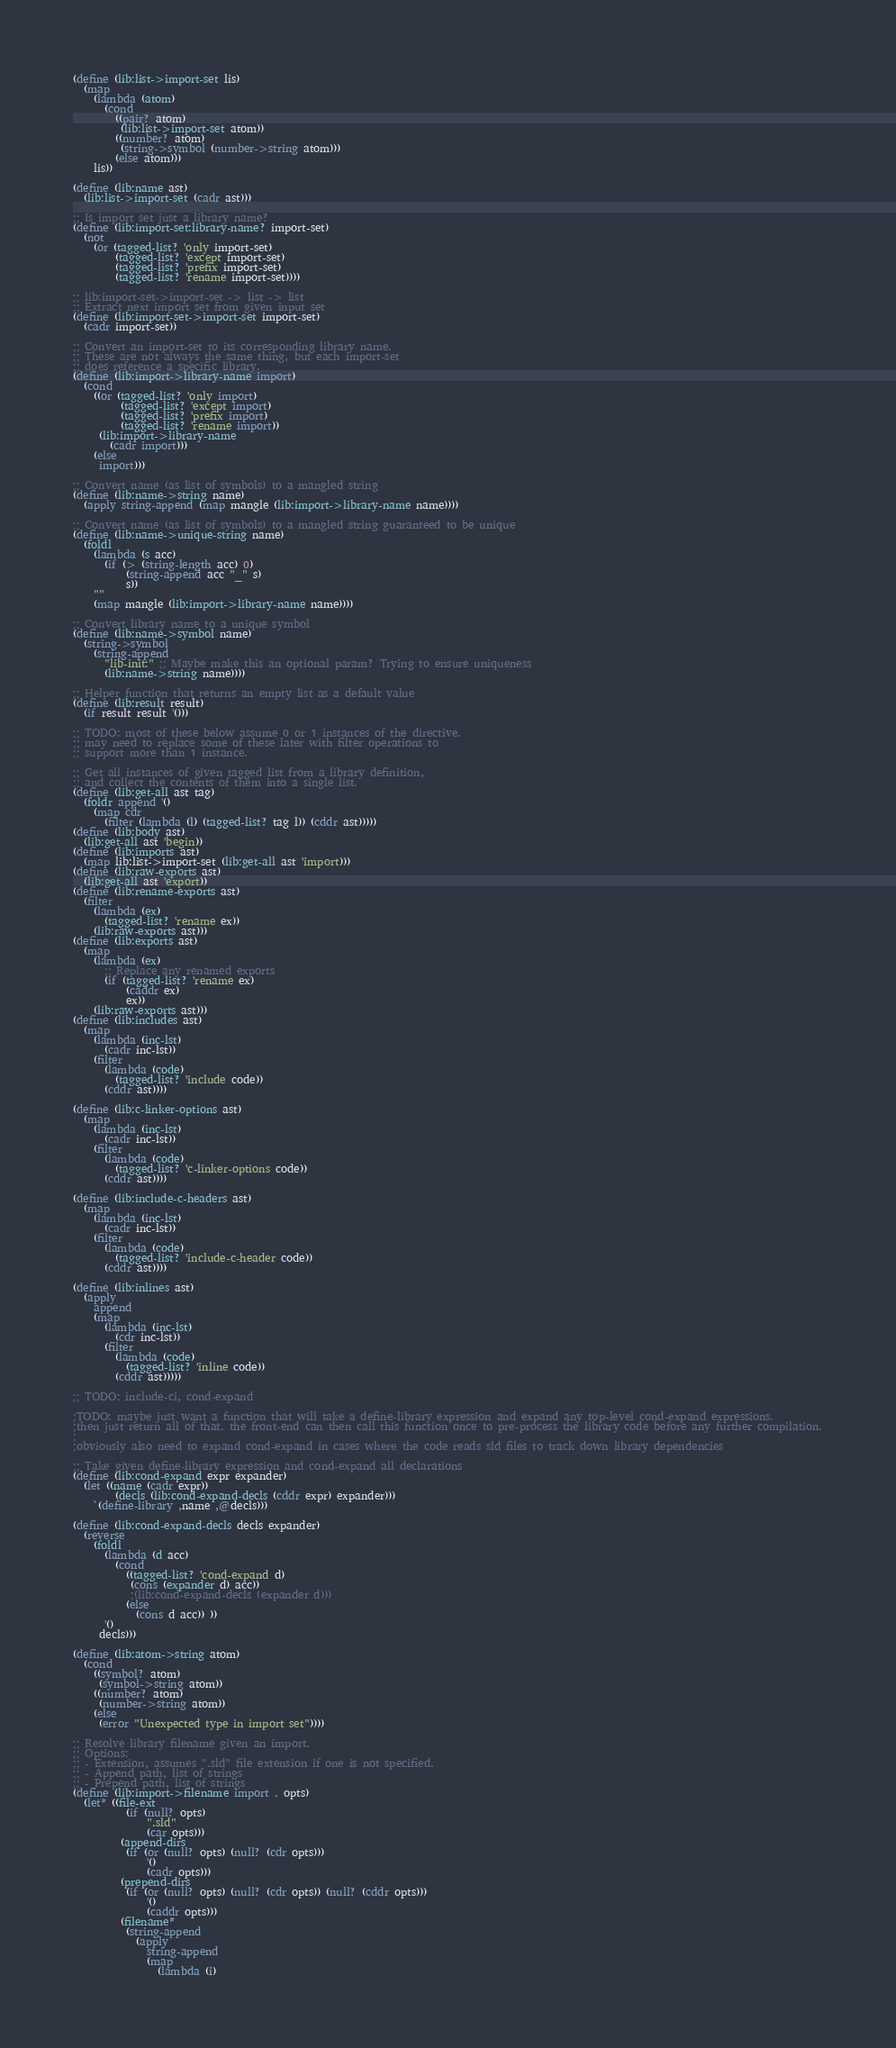Convert code to text. <code><loc_0><loc_0><loc_500><loc_500><_Scheme_>(define (lib:list->import-set lis)
  (map
    (lambda (atom)
      (cond
        ((pair? atom)
         (lib:list->import-set atom))
        ((number? atom)
         (string->symbol (number->string atom)))
        (else atom)))
    lis))

(define (lib:name ast) 
  (lib:list->import-set (cadr ast)))

;; Is import set just a library name?
(define (lib:import-set:library-name? import-set)
  (not
    (or (tagged-list? 'only import-set)
        (tagged-list? 'except import-set)
        (tagged-list? 'prefix import-set)
        (tagged-list? 'rename import-set))))

;; lib:import-set->import-set -> list -> list
;; Extract next import set from given input set
(define (lib:import-set->import-set import-set)
  (cadr import-set))

;; Convert an import-set to its corresponding library name.
;; These are not always the same thing, but each import-set
;; does reference a specific library.
(define (lib:import->library-name import)
  (cond
    ((or (tagged-list? 'only import)
         (tagged-list? 'except import)
         (tagged-list? 'prefix import)
         (tagged-list? 'rename import))
     (lib:import->library-name 
       (cadr import)))
    (else
     import)))

;; Convert name (as list of symbols) to a mangled string
(define (lib:name->string name)
  (apply string-append (map mangle (lib:import->library-name name))))

;; Convert name (as list of symbols) to a mangled string guaranteed to be unique
(define (lib:name->unique-string name)
  (foldl
    (lambda (s acc)
      (if (> (string-length acc) 0)
          (string-append acc "_" s)
          s))
    ""
    (map mangle (lib:import->library-name name))))

;; Convert library name to a unique symbol
(define (lib:name->symbol name)
  (string->symbol 
    (string-append
      "lib-init:" ;; Maybe make this an optional param? Trying to ensure uniqueness
      (lib:name->string name))))

;; Helper function that returns an empty list as a default value
(define (lib:result result)
  (if result result '()))

;; TODO: most of these below assume 0 or 1 instances of the directive.
;; may need to replace some of these later with filter operations to
;; support more than 1 instance.

;; Get all instances of given tagged list from a library definition,
;; and collect the contents of them into a single list.
(define (lib:get-all ast tag)
  (foldr append '()
    (map cdr 
      (filter (lambda (l) (tagged-list? tag l)) (cddr ast)))))
(define (lib:body ast) 
  (lib:get-all ast 'begin))
(define (lib:imports ast) 
  (map lib:list->import-set (lib:get-all ast 'import)))
(define (lib:raw-exports ast) 
  (lib:get-all ast 'export))
(define (lib:rename-exports ast)
  (filter
    (lambda (ex)
      (tagged-list? 'rename ex))
    (lib:raw-exports ast)))
(define (lib:exports ast)
  (map
    (lambda (ex)
      ;; Replace any renamed exports
      (if (tagged-list? 'rename ex)
          (caddr ex)
          ex))
    (lib:raw-exports ast)))
(define (lib:includes ast)
  (map
    (lambda (inc-lst)
      (cadr inc-lst))
    (filter
      (lambda (code)
        (tagged-list? 'include code))
      (cddr ast))))

(define (lib:c-linker-options ast)
  (map
    (lambda (inc-lst)
      (cadr inc-lst))
    (filter
      (lambda (code)
        (tagged-list? 'c-linker-options code))
      (cddr ast))))

(define (lib:include-c-headers ast)
  (map
    (lambda (inc-lst)
      (cadr inc-lst))
    (filter
      (lambda (code)
        (tagged-list? 'include-c-header code))
      (cddr ast))))

(define (lib:inlines ast)
  (apply 
    append
    (map
      (lambda (inc-lst)
        (cdr inc-lst))
      (filter
        (lambda (code)
          (tagged-list? 'inline code))
        (cddr ast)))))

;; TODO: include-ci, cond-expand

;TODO: maybe just want a function that will take a define-library expression and expand any top-level cond-expand expressions.
;then just return all of that. the front-end can then call this function once to pre-process the library code before any further compilation.
;
;obviously also need to expand cond-expand in cases where the code reads sld files to track down library dependencies

;; Take given define-library expression and cond-expand all declarations
(define (lib:cond-expand expr expander)
  (let ((name (cadr expr))
        (decls (lib:cond-expand-decls (cddr expr) expander)))
    `(define-library ,name ,@decls)))

(define (lib:cond-expand-decls decls expander)
  (reverse
    (foldl 
      (lambda (d acc) 
        (cond
          ((tagged-list? 'cond-expand d)
           (cons (expander d) acc))
           ;(lib:cond-expand-decls (expander d)))
          (else
            (cons d acc)) ))
      '() 
     decls)))

(define (lib:atom->string atom)
  (cond
    ((symbol? atom)
     (symbol->string atom))
    ((number? atom)
     (number->string atom))
    (else
     (error "Unexpected type in import set"))))

;; Resolve library filename given an import. 
;; Options:
;; - Extension, assumes ".sld" file extension if one is not specified.
;; - Append path, list of strings
;; - Prepend path, list of strings
(define (lib:import->filename import . opts)
  (let* ((file-ext 
          (if (null? opts)
              ".sld"
              (car opts)))
         (append-dirs
          (if (or (null? opts) (null? (cdr opts)))
              '()
              (cadr opts)))
         (prepend-dirs
          (if (or (null? opts) (null? (cdr opts)) (null? (cddr opts)))
              '()
              (caddr opts)))
         (filename*
          (string-append
            (apply
              string-append
              (map 
                (lambda (i) </code> 